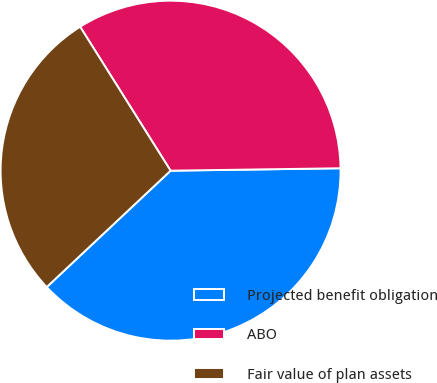<chart> <loc_0><loc_0><loc_500><loc_500><pie_chart><fcel>Projected benefit obligation<fcel>ABO<fcel>Fair value of plan assets<nl><fcel>38.22%<fcel>33.7%<fcel>28.07%<nl></chart> 